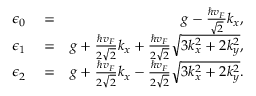<formula> <loc_0><loc_0><loc_500><loc_500>\begin{array} { r l r } { \epsilon _ { 0 } } & = } & { g - \frac { \hbar { v } _ { F } } { \sqrt { 2 } } k _ { x } , } \\ { \epsilon _ { 1 } } & = } & { g + \frac { \hbar { v } _ { F } } { 2 \sqrt { 2 } } k _ { x } + \frac { \hbar { v } _ { F } } { 2 \sqrt { 2 } } \sqrt { 3 k _ { x } ^ { 2 } + 2 k _ { y } ^ { 2 } } , } \\ { \epsilon _ { 2 } } & = } & { g + \frac { \hbar { v } _ { F } } { 2 \sqrt { 2 } } k _ { x } - \frac { \hbar { v } _ { F } } { 2 \sqrt { 2 } } \sqrt { 3 k _ { x } ^ { 2 } + 2 k _ { y } ^ { 2 } } . } \end{array}</formula> 